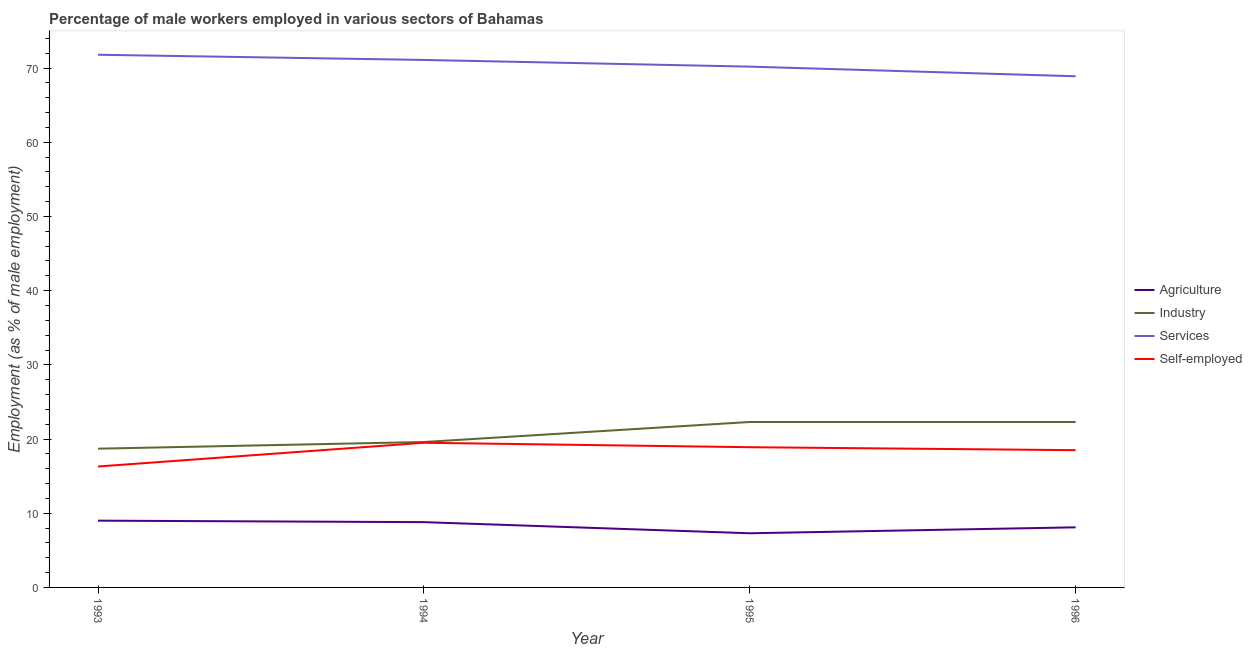Across all years, what is the maximum percentage of self employed male workers?
Provide a short and direct response. 19.5. Across all years, what is the minimum percentage of male workers in services?
Keep it short and to the point. 68.9. In which year was the percentage of male workers in agriculture maximum?
Offer a terse response. 1993. In which year was the percentage of male workers in agriculture minimum?
Ensure brevity in your answer.  1995. What is the total percentage of male workers in agriculture in the graph?
Offer a terse response. 33.2. What is the difference between the percentage of self employed male workers in 1993 and that in 1994?
Keep it short and to the point. -3.2. What is the difference between the percentage of male workers in industry in 1993 and the percentage of male workers in agriculture in 1994?
Your answer should be compact. 9.9. What is the average percentage of male workers in services per year?
Give a very brief answer. 70.5. In the year 1996, what is the difference between the percentage of male workers in agriculture and percentage of self employed male workers?
Ensure brevity in your answer.  -10.4. In how many years, is the percentage of self employed male workers greater than 14 %?
Ensure brevity in your answer.  4. What is the ratio of the percentage of male workers in agriculture in 1993 to that in 1995?
Ensure brevity in your answer.  1.23. Is the percentage of male workers in agriculture in 1995 less than that in 1996?
Offer a very short reply. Yes. What is the difference between the highest and the second highest percentage of male workers in services?
Provide a short and direct response. 0.7. What is the difference between the highest and the lowest percentage of male workers in industry?
Keep it short and to the point. 3.6. In how many years, is the percentage of male workers in industry greater than the average percentage of male workers in industry taken over all years?
Your answer should be compact. 2. Does the percentage of male workers in industry monotonically increase over the years?
Offer a very short reply. No. Is the percentage of self employed male workers strictly greater than the percentage of male workers in agriculture over the years?
Give a very brief answer. Yes. What is the difference between two consecutive major ticks on the Y-axis?
Offer a very short reply. 10. Does the graph contain any zero values?
Offer a very short reply. No. Where does the legend appear in the graph?
Your answer should be very brief. Center right. What is the title of the graph?
Give a very brief answer. Percentage of male workers employed in various sectors of Bahamas. What is the label or title of the Y-axis?
Provide a succinct answer. Employment (as % of male employment). What is the Employment (as % of male employment) of Agriculture in 1993?
Make the answer very short. 9. What is the Employment (as % of male employment) in Industry in 1993?
Provide a short and direct response. 18.7. What is the Employment (as % of male employment) of Services in 1993?
Give a very brief answer. 71.8. What is the Employment (as % of male employment) in Self-employed in 1993?
Offer a terse response. 16.3. What is the Employment (as % of male employment) of Agriculture in 1994?
Make the answer very short. 8.8. What is the Employment (as % of male employment) of Industry in 1994?
Your response must be concise. 19.6. What is the Employment (as % of male employment) in Services in 1994?
Provide a short and direct response. 71.1. What is the Employment (as % of male employment) in Agriculture in 1995?
Your answer should be compact. 7.3. What is the Employment (as % of male employment) in Industry in 1995?
Make the answer very short. 22.3. What is the Employment (as % of male employment) of Services in 1995?
Your answer should be very brief. 70.2. What is the Employment (as % of male employment) of Self-employed in 1995?
Your response must be concise. 18.9. What is the Employment (as % of male employment) in Agriculture in 1996?
Give a very brief answer. 8.1. What is the Employment (as % of male employment) in Industry in 1996?
Your answer should be very brief. 22.3. What is the Employment (as % of male employment) of Services in 1996?
Offer a very short reply. 68.9. Across all years, what is the maximum Employment (as % of male employment) in Agriculture?
Your answer should be compact. 9. Across all years, what is the maximum Employment (as % of male employment) in Industry?
Give a very brief answer. 22.3. Across all years, what is the maximum Employment (as % of male employment) in Services?
Provide a short and direct response. 71.8. Across all years, what is the maximum Employment (as % of male employment) in Self-employed?
Provide a succinct answer. 19.5. Across all years, what is the minimum Employment (as % of male employment) of Agriculture?
Your answer should be compact. 7.3. Across all years, what is the minimum Employment (as % of male employment) of Industry?
Provide a short and direct response. 18.7. Across all years, what is the minimum Employment (as % of male employment) in Services?
Provide a short and direct response. 68.9. Across all years, what is the minimum Employment (as % of male employment) of Self-employed?
Offer a very short reply. 16.3. What is the total Employment (as % of male employment) of Agriculture in the graph?
Your answer should be compact. 33.2. What is the total Employment (as % of male employment) of Industry in the graph?
Your response must be concise. 82.9. What is the total Employment (as % of male employment) in Services in the graph?
Provide a succinct answer. 282. What is the total Employment (as % of male employment) in Self-employed in the graph?
Provide a short and direct response. 73.2. What is the difference between the Employment (as % of male employment) of Agriculture in 1993 and that in 1994?
Your answer should be very brief. 0.2. What is the difference between the Employment (as % of male employment) of Self-employed in 1993 and that in 1994?
Provide a succinct answer. -3.2. What is the difference between the Employment (as % of male employment) of Agriculture in 1993 and that in 1995?
Provide a succinct answer. 1.7. What is the difference between the Employment (as % of male employment) of Services in 1993 and that in 1995?
Make the answer very short. 1.6. What is the difference between the Employment (as % of male employment) of Self-employed in 1993 and that in 1995?
Provide a succinct answer. -2.6. What is the difference between the Employment (as % of male employment) of Services in 1993 and that in 1996?
Give a very brief answer. 2.9. What is the difference between the Employment (as % of male employment) of Self-employed in 1993 and that in 1996?
Offer a very short reply. -2.2. What is the difference between the Employment (as % of male employment) of Agriculture in 1994 and that in 1995?
Provide a short and direct response. 1.5. What is the difference between the Employment (as % of male employment) in Industry in 1994 and that in 1995?
Your response must be concise. -2.7. What is the difference between the Employment (as % of male employment) of Self-employed in 1994 and that in 1995?
Provide a short and direct response. 0.6. What is the difference between the Employment (as % of male employment) of Services in 1994 and that in 1996?
Your response must be concise. 2.2. What is the difference between the Employment (as % of male employment) of Agriculture in 1995 and that in 1996?
Provide a short and direct response. -0.8. What is the difference between the Employment (as % of male employment) in Industry in 1995 and that in 1996?
Offer a very short reply. 0. What is the difference between the Employment (as % of male employment) in Agriculture in 1993 and the Employment (as % of male employment) in Industry in 1994?
Provide a short and direct response. -10.6. What is the difference between the Employment (as % of male employment) in Agriculture in 1993 and the Employment (as % of male employment) in Services in 1994?
Offer a terse response. -62.1. What is the difference between the Employment (as % of male employment) in Industry in 1993 and the Employment (as % of male employment) in Services in 1994?
Provide a succinct answer. -52.4. What is the difference between the Employment (as % of male employment) in Industry in 1993 and the Employment (as % of male employment) in Self-employed in 1994?
Offer a very short reply. -0.8. What is the difference between the Employment (as % of male employment) of Services in 1993 and the Employment (as % of male employment) of Self-employed in 1994?
Offer a terse response. 52.3. What is the difference between the Employment (as % of male employment) of Agriculture in 1993 and the Employment (as % of male employment) of Services in 1995?
Your answer should be very brief. -61.2. What is the difference between the Employment (as % of male employment) of Agriculture in 1993 and the Employment (as % of male employment) of Self-employed in 1995?
Provide a succinct answer. -9.9. What is the difference between the Employment (as % of male employment) in Industry in 1993 and the Employment (as % of male employment) in Services in 1995?
Offer a terse response. -51.5. What is the difference between the Employment (as % of male employment) in Industry in 1993 and the Employment (as % of male employment) in Self-employed in 1995?
Keep it short and to the point. -0.2. What is the difference between the Employment (as % of male employment) of Services in 1993 and the Employment (as % of male employment) of Self-employed in 1995?
Keep it short and to the point. 52.9. What is the difference between the Employment (as % of male employment) in Agriculture in 1993 and the Employment (as % of male employment) in Services in 1996?
Provide a short and direct response. -59.9. What is the difference between the Employment (as % of male employment) in Industry in 1993 and the Employment (as % of male employment) in Services in 1996?
Keep it short and to the point. -50.2. What is the difference between the Employment (as % of male employment) in Industry in 1993 and the Employment (as % of male employment) in Self-employed in 1996?
Your answer should be very brief. 0.2. What is the difference between the Employment (as % of male employment) of Services in 1993 and the Employment (as % of male employment) of Self-employed in 1996?
Offer a very short reply. 53.3. What is the difference between the Employment (as % of male employment) of Agriculture in 1994 and the Employment (as % of male employment) of Services in 1995?
Make the answer very short. -61.4. What is the difference between the Employment (as % of male employment) in Agriculture in 1994 and the Employment (as % of male employment) in Self-employed in 1995?
Ensure brevity in your answer.  -10.1. What is the difference between the Employment (as % of male employment) in Industry in 1994 and the Employment (as % of male employment) in Services in 1995?
Give a very brief answer. -50.6. What is the difference between the Employment (as % of male employment) in Industry in 1994 and the Employment (as % of male employment) in Self-employed in 1995?
Offer a terse response. 0.7. What is the difference between the Employment (as % of male employment) of Services in 1994 and the Employment (as % of male employment) of Self-employed in 1995?
Provide a succinct answer. 52.2. What is the difference between the Employment (as % of male employment) in Agriculture in 1994 and the Employment (as % of male employment) in Services in 1996?
Provide a short and direct response. -60.1. What is the difference between the Employment (as % of male employment) of Agriculture in 1994 and the Employment (as % of male employment) of Self-employed in 1996?
Ensure brevity in your answer.  -9.7. What is the difference between the Employment (as % of male employment) of Industry in 1994 and the Employment (as % of male employment) of Services in 1996?
Your answer should be very brief. -49.3. What is the difference between the Employment (as % of male employment) of Industry in 1994 and the Employment (as % of male employment) of Self-employed in 1996?
Make the answer very short. 1.1. What is the difference between the Employment (as % of male employment) of Services in 1994 and the Employment (as % of male employment) of Self-employed in 1996?
Your answer should be very brief. 52.6. What is the difference between the Employment (as % of male employment) in Agriculture in 1995 and the Employment (as % of male employment) in Services in 1996?
Give a very brief answer. -61.6. What is the difference between the Employment (as % of male employment) of Agriculture in 1995 and the Employment (as % of male employment) of Self-employed in 1996?
Make the answer very short. -11.2. What is the difference between the Employment (as % of male employment) in Industry in 1995 and the Employment (as % of male employment) in Services in 1996?
Make the answer very short. -46.6. What is the difference between the Employment (as % of male employment) in Services in 1995 and the Employment (as % of male employment) in Self-employed in 1996?
Provide a short and direct response. 51.7. What is the average Employment (as % of male employment) of Industry per year?
Provide a short and direct response. 20.73. What is the average Employment (as % of male employment) of Services per year?
Your answer should be compact. 70.5. In the year 1993, what is the difference between the Employment (as % of male employment) of Agriculture and Employment (as % of male employment) of Industry?
Provide a succinct answer. -9.7. In the year 1993, what is the difference between the Employment (as % of male employment) in Agriculture and Employment (as % of male employment) in Services?
Make the answer very short. -62.8. In the year 1993, what is the difference between the Employment (as % of male employment) of Industry and Employment (as % of male employment) of Services?
Your answer should be very brief. -53.1. In the year 1993, what is the difference between the Employment (as % of male employment) of Services and Employment (as % of male employment) of Self-employed?
Your response must be concise. 55.5. In the year 1994, what is the difference between the Employment (as % of male employment) of Agriculture and Employment (as % of male employment) of Services?
Offer a very short reply. -62.3. In the year 1994, what is the difference between the Employment (as % of male employment) of Agriculture and Employment (as % of male employment) of Self-employed?
Offer a very short reply. -10.7. In the year 1994, what is the difference between the Employment (as % of male employment) in Industry and Employment (as % of male employment) in Services?
Keep it short and to the point. -51.5. In the year 1994, what is the difference between the Employment (as % of male employment) in Industry and Employment (as % of male employment) in Self-employed?
Offer a terse response. 0.1. In the year 1994, what is the difference between the Employment (as % of male employment) of Services and Employment (as % of male employment) of Self-employed?
Offer a very short reply. 51.6. In the year 1995, what is the difference between the Employment (as % of male employment) in Agriculture and Employment (as % of male employment) in Services?
Your answer should be very brief. -62.9. In the year 1995, what is the difference between the Employment (as % of male employment) in Agriculture and Employment (as % of male employment) in Self-employed?
Provide a succinct answer. -11.6. In the year 1995, what is the difference between the Employment (as % of male employment) in Industry and Employment (as % of male employment) in Services?
Offer a very short reply. -47.9. In the year 1995, what is the difference between the Employment (as % of male employment) in Services and Employment (as % of male employment) in Self-employed?
Make the answer very short. 51.3. In the year 1996, what is the difference between the Employment (as % of male employment) in Agriculture and Employment (as % of male employment) in Services?
Provide a succinct answer. -60.8. In the year 1996, what is the difference between the Employment (as % of male employment) in Industry and Employment (as % of male employment) in Services?
Ensure brevity in your answer.  -46.6. In the year 1996, what is the difference between the Employment (as % of male employment) of Services and Employment (as % of male employment) of Self-employed?
Your answer should be compact. 50.4. What is the ratio of the Employment (as % of male employment) in Agriculture in 1993 to that in 1994?
Offer a very short reply. 1.02. What is the ratio of the Employment (as % of male employment) in Industry in 1993 to that in 1994?
Offer a terse response. 0.95. What is the ratio of the Employment (as % of male employment) of Services in 1993 to that in 1994?
Keep it short and to the point. 1.01. What is the ratio of the Employment (as % of male employment) of Self-employed in 1993 to that in 1994?
Ensure brevity in your answer.  0.84. What is the ratio of the Employment (as % of male employment) of Agriculture in 1993 to that in 1995?
Provide a short and direct response. 1.23. What is the ratio of the Employment (as % of male employment) in Industry in 1993 to that in 1995?
Make the answer very short. 0.84. What is the ratio of the Employment (as % of male employment) in Services in 1993 to that in 1995?
Provide a short and direct response. 1.02. What is the ratio of the Employment (as % of male employment) of Self-employed in 1993 to that in 1995?
Make the answer very short. 0.86. What is the ratio of the Employment (as % of male employment) in Industry in 1993 to that in 1996?
Keep it short and to the point. 0.84. What is the ratio of the Employment (as % of male employment) in Services in 1993 to that in 1996?
Your answer should be compact. 1.04. What is the ratio of the Employment (as % of male employment) of Self-employed in 1993 to that in 1996?
Provide a short and direct response. 0.88. What is the ratio of the Employment (as % of male employment) of Agriculture in 1994 to that in 1995?
Make the answer very short. 1.21. What is the ratio of the Employment (as % of male employment) of Industry in 1994 to that in 1995?
Give a very brief answer. 0.88. What is the ratio of the Employment (as % of male employment) in Services in 1994 to that in 1995?
Give a very brief answer. 1.01. What is the ratio of the Employment (as % of male employment) of Self-employed in 1994 to that in 1995?
Give a very brief answer. 1.03. What is the ratio of the Employment (as % of male employment) of Agriculture in 1994 to that in 1996?
Ensure brevity in your answer.  1.09. What is the ratio of the Employment (as % of male employment) of Industry in 1994 to that in 1996?
Offer a very short reply. 0.88. What is the ratio of the Employment (as % of male employment) of Services in 1994 to that in 1996?
Your answer should be very brief. 1.03. What is the ratio of the Employment (as % of male employment) in Self-employed in 1994 to that in 1996?
Your answer should be compact. 1.05. What is the ratio of the Employment (as % of male employment) of Agriculture in 1995 to that in 1996?
Ensure brevity in your answer.  0.9. What is the ratio of the Employment (as % of male employment) in Industry in 1995 to that in 1996?
Your answer should be compact. 1. What is the ratio of the Employment (as % of male employment) in Services in 1995 to that in 1996?
Give a very brief answer. 1.02. What is the ratio of the Employment (as % of male employment) in Self-employed in 1995 to that in 1996?
Offer a very short reply. 1.02. What is the difference between the highest and the lowest Employment (as % of male employment) in Services?
Offer a terse response. 2.9. What is the difference between the highest and the lowest Employment (as % of male employment) in Self-employed?
Give a very brief answer. 3.2. 